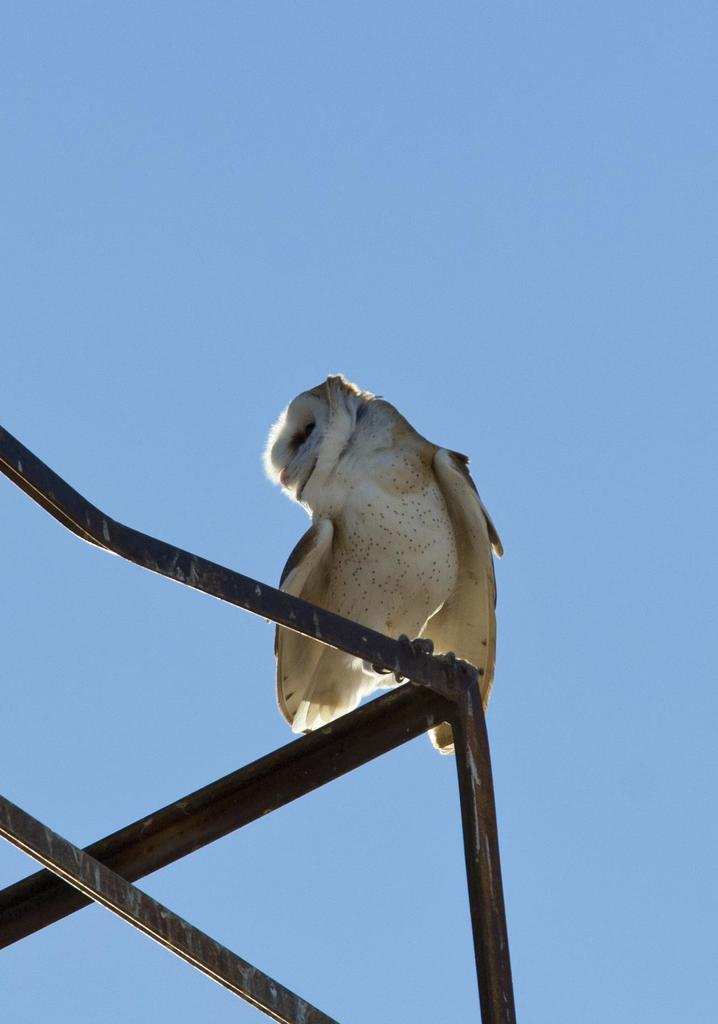What type of animal can be seen in the image? There is a bird in the image. Where is the bird located? The bird is on a metal fence. What colors can be observed on the bird? The bird is white and brown in color. What is the color of the sky in the image? The sky is blue in the image. How many legs does the bird have in the image? The bird has two legs, but this question is irrelevant to the image as it does not focus on any specific detail provided in the facts. 